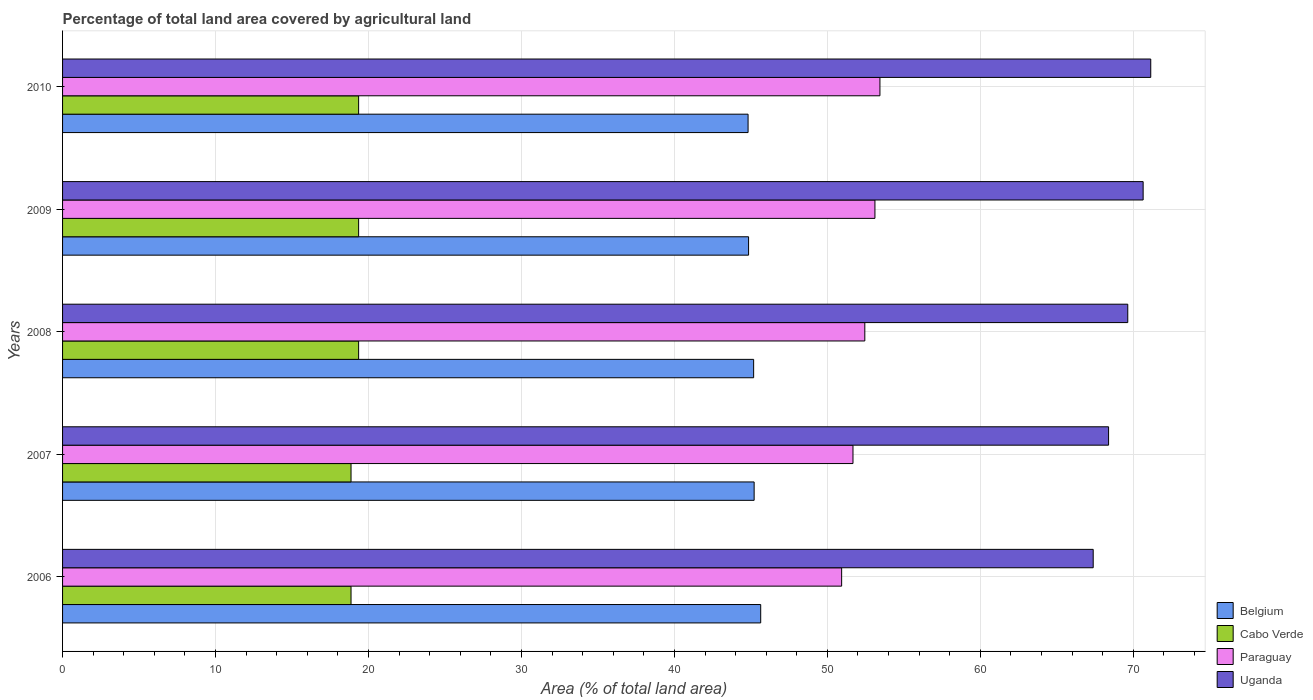How many bars are there on the 4th tick from the top?
Your answer should be compact. 4. What is the label of the 3rd group of bars from the top?
Your answer should be compact. 2008. What is the percentage of agricultural land in Belgium in 2008?
Give a very brief answer. 45.18. Across all years, what is the maximum percentage of agricultural land in Cabo Verde?
Provide a short and direct response. 19.35. Across all years, what is the minimum percentage of agricultural land in Uganda?
Ensure brevity in your answer.  67.38. What is the total percentage of agricultural land in Belgium in the graph?
Make the answer very short. 225.69. What is the difference between the percentage of agricultural land in Cabo Verde in 2007 and that in 2010?
Keep it short and to the point. -0.5. What is the difference between the percentage of agricultural land in Cabo Verde in 2006 and the percentage of agricultural land in Belgium in 2007?
Keep it short and to the point. -26.35. What is the average percentage of agricultural land in Paraguay per year?
Make the answer very short. 52.32. In the year 2007, what is the difference between the percentage of agricultural land in Cabo Verde and percentage of agricultural land in Uganda?
Ensure brevity in your answer.  -49.52. In how many years, is the percentage of agricultural land in Belgium greater than 66 %?
Keep it short and to the point. 0. What is the ratio of the percentage of agricultural land in Paraguay in 2007 to that in 2008?
Your answer should be compact. 0.99. Is the percentage of agricultural land in Cabo Verde in 2008 less than that in 2009?
Your answer should be very brief. No. Is the difference between the percentage of agricultural land in Cabo Verde in 2007 and 2009 greater than the difference between the percentage of agricultural land in Uganda in 2007 and 2009?
Your answer should be very brief. Yes. What is the difference between the highest and the second highest percentage of agricultural land in Uganda?
Your answer should be very brief. 0.5. What is the difference between the highest and the lowest percentage of agricultural land in Belgium?
Offer a very short reply. 0.83. In how many years, is the percentage of agricultural land in Paraguay greater than the average percentage of agricultural land in Paraguay taken over all years?
Give a very brief answer. 3. Is it the case that in every year, the sum of the percentage of agricultural land in Belgium and percentage of agricultural land in Paraguay is greater than the sum of percentage of agricultural land in Uganda and percentage of agricultural land in Cabo Verde?
Your answer should be compact. No. What does the 2nd bar from the top in 2010 represents?
Ensure brevity in your answer.  Paraguay. Is it the case that in every year, the sum of the percentage of agricultural land in Cabo Verde and percentage of agricultural land in Uganda is greater than the percentage of agricultural land in Belgium?
Offer a very short reply. Yes. How many bars are there?
Make the answer very short. 20. What is the difference between two consecutive major ticks on the X-axis?
Your answer should be compact. 10. Does the graph contain any zero values?
Keep it short and to the point. No. Where does the legend appear in the graph?
Make the answer very short. Bottom right. How many legend labels are there?
Offer a very short reply. 4. How are the legend labels stacked?
Offer a very short reply. Vertical. What is the title of the graph?
Your answer should be very brief. Percentage of total land area covered by agricultural land. What is the label or title of the X-axis?
Provide a succinct answer. Area (% of total land area). What is the Area (% of total land area) in Belgium in 2006?
Offer a terse response. 45.64. What is the Area (% of total land area) in Cabo Verde in 2006?
Ensure brevity in your answer.  18.86. What is the Area (% of total land area) in Paraguay in 2006?
Provide a short and direct response. 50.93. What is the Area (% of total land area) of Uganda in 2006?
Ensure brevity in your answer.  67.38. What is the Area (% of total land area) in Belgium in 2007?
Your response must be concise. 45.21. What is the Area (% of total land area) in Cabo Verde in 2007?
Make the answer very short. 18.86. What is the Area (% of total land area) of Paraguay in 2007?
Offer a terse response. 51.67. What is the Area (% of total land area) in Uganda in 2007?
Your answer should be compact. 68.38. What is the Area (% of total land area) in Belgium in 2008?
Give a very brief answer. 45.18. What is the Area (% of total land area) of Cabo Verde in 2008?
Make the answer very short. 19.35. What is the Area (% of total land area) in Paraguay in 2008?
Your answer should be compact. 52.45. What is the Area (% of total land area) of Uganda in 2008?
Give a very brief answer. 69.64. What is the Area (% of total land area) in Belgium in 2009?
Make the answer very short. 44.85. What is the Area (% of total land area) of Cabo Verde in 2009?
Your response must be concise. 19.35. What is the Area (% of total land area) in Paraguay in 2009?
Give a very brief answer. 53.11. What is the Area (% of total land area) in Uganda in 2009?
Ensure brevity in your answer.  70.64. What is the Area (% of total land area) of Belgium in 2010?
Provide a succinct answer. 44.82. What is the Area (% of total land area) in Cabo Verde in 2010?
Provide a succinct answer. 19.35. What is the Area (% of total land area) of Paraguay in 2010?
Your answer should be compact. 53.44. What is the Area (% of total land area) in Uganda in 2010?
Offer a very short reply. 71.14. Across all years, what is the maximum Area (% of total land area) of Belgium?
Your answer should be compact. 45.64. Across all years, what is the maximum Area (% of total land area) in Cabo Verde?
Your response must be concise. 19.35. Across all years, what is the maximum Area (% of total land area) in Paraguay?
Provide a short and direct response. 53.44. Across all years, what is the maximum Area (% of total land area) of Uganda?
Your answer should be very brief. 71.14. Across all years, what is the minimum Area (% of total land area) in Belgium?
Offer a very short reply. 44.82. Across all years, what is the minimum Area (% of total land area) in Cabo Verde?
Offer a very short reply. 18.86. Across all years, what is the minimum Area (% of total land area) in Paraguay?
Offer a terse response. 50.93. Across all years, what is the minimum Area (% of total land area) in Uganda?
Make the answer very short. 67.38. What is the total Area (% of total land area) in Belgium in the graph?
Offer a terse response. 225.69. What is the total Area (% of total land area) of Cabo Verde in the graph?
Provide a short and direct response. 95.78. What is the total Area (% of total land area) of Paraguay in the graph?
Your answer should be very brief. 261.6. What is the total Area (% of total land area) of Uganda in the graph?
Your response must be concise. 347.18. What is the difference between the Area (% of total land area) of Belgium in 2006 and that in 2007?
Give a very brief answer. 0.43. What is the difference between the Area (% of total land area) of Paraguay in 2006 and that in 2007?
Your response must be concise. -0.74. What is the difference between the Area (% of total land area) in Uganda in 2006 and that in 2007?
Keep it short and to the point. -1. What is the difference between the Area (% of total land area) in Belgium in 2006 and that in 2008?
Your answer should be very brief. 0.46. What is the difference between the Area (% of total land area) in Cabo Verde in 2006 and that in 2008?
Offer a terse response. -0.5. What is the difference between the Area (% of total land area) of Paraguay in 2006 and that in 2008?
Provide a short and direct response. -1.52. What is the difference between the Area (% of total land area) in Uganda in 2006 and that in 2008?
Offer a terse response. -2.26. What is the difference between the Area (% of total land area) in Belgium in 2006 and that in 2009?
Ensure brevity in your answer.  0.79. What is the difference between the Area (% of total land area) of Cabo Verde in 2006 and that in 2009?
Offer a terse response. -0.5. What is the difference between the Area (% of total land area) of Paraguay in 2006 and that in 2009?
Provide a short and direct response. -2.18. What is the difference between the Area (% of total land area) in Uganda in 2006 and that in 2009?
Give a very brief answer. -3.26. What is the difference between the Area (% of total land area) of Belgium in 2006 and that in 2010?
Offer a very short reply. 0.83. What is the difference between the Area (% of total land area) in Cabo Verde in 2006 and that in 2010?
Offer a very short reply. -0.5. What is the difference between the Area (% of total land area) of Paraguay in 2006 and that in 2010?
Your answer should be very brief. -2.5. What is the difference between the Area (% of total land area) in Uganda in 2006 and that in 2010?
Your answer should be very brief. -3.76. What is the difference between the Area (% of total land area) in Belgium in 2007 and that in 2008?
Provide a succinct answer. 0.03. What is the difference between the Area (% of total land area) in Cabo Verde in 2007 and that in 2008?
Ensure brevity in your answer.  -0.5. What is the difference between the Area (% of total land area) in Paraguay in 2007 and that in 2008?
Make the answer very short. -0.77. What is the difference between the Area (% of total land area) in Uganda in 2007 and that in 2008?
Ensure brevity in your answer.  -1.25. What is the difference between the Area (% of total land area) of Belgium in 2007 and that in 2009?
Provide a short and direct response. 0.36. What is the difference between the Area (% of total land area) in Cabo Verde in 2007 and that in 2009?
Offer a terse response. -0.5. What is the difference between the Area (% of total land area) of Paraguay in 2007 and that in 2009?
Your answer should be very brief. -1.43. What is the difference between the Area (% of total land area) in Uganda in 2007 and that in 2009?
Provide a succinct answer. -2.26. What is the difference between the Area (% of total land area) in Belgium in 2007 and that in 2010?
Provide a short and direct response. 0.4. What is the difference between the Area (% of total land area) of Cabo Verde in 2007 and that in 2010?
Offer a terse response. -0.5. What is the difference between the Area (% of total land area) of Paraguay in 2007 and that in 2010?
Give a very brief answer. -1.76. What is the difference between the Area (% of total land area) in Uganda in 2007 and that in 2010?
Keep it short and to the point. -2.76. What is the difference between the Area (% of total land area) in Belgium in 2008 and that in 2009?
Your answer should be very brief. 0.33. What is the difference between the Area (% of total land area) of Cabo Verde in 2008 and that in 2009?
Provide a short and direct response. 0. What is the difference between the Area (% of total land area) of Paraguay in 2008 and that in 2009?
Make the answer very short. -0.66. What is the difference between the Area (% of total land area) in Uganda in 2008 and that in 2009?
Provide a short and direct response. -1. What is the difference between the Area (% of total land area) in Belgium in 2008 and that in 2010?
Your answer should be compact. 0.36. What is the difference between the Area (% of total land area) in Paraguay in 2008 and that in 2010?
Offer a very short reply. -0.99. What is the difference between the Area (% of total land area) in Uganda in 2008 and that in 2010?
Provide a short and direct response. -1.5. What is the difference between the Area (% of total land area) in Belgium in 2009 and that in 2010?
Provide a short and direct response. 0.03. What is the difference between the Area (% of total land area) in Cabo Verde in 2009 and that in 2010?
Provide a succinct answer. 0. What is the difference between the Area (% of total land area) in Paraguay in 2009 and that in 2010?
Offer a terse response. -0.33. What is the difference between the Area (% of total land area) in Uganda in 2009 and that in 2010?
Keep it short and to the point. -0.5. What is the difference between the Area (% of total land area) in Belgium in 2006 and the Area (% of total land area) in Cabo Verde in 2007?
Provide a succinct answer. 26.78. What is the difference between the Area (% of total land area) of Belgium in 2006 and the Area (% of total land area) of Paraguay in 2007?
Your response must be concise. -6.03. What is the difference between the Area (% of total land area) in Belgium in 2006 and the Area (% of total land area) in Uganda in 2007?
Provide a succinct answer. -22.74. What is the difference between the Area (% of total land area) in Cabo Verde in 2006 and the Area (% of total land area) in Paraguay in 2007?
Ensure brevity in your answer.  -32.82. What is the difference between the Area (% of total land area) of Cabo Verde in 2006 and the Area (% of total land area) of Uganda in 2007?
Your answer should be very brief. -49.52. What is the difference between the Area (% of total land area) of Paraguay in 2006 and the Area (% of total land area) of Uganda in 2007?
Offer a very short reply. -17.45. What is the difference between the Area (% of total land area) in Belgium in 2006 and the Area (% of total land area) in Cabo Verde in 2008?
Offer a very short reply. 26.29. What is the difference between the Area (% of total land area) of Belgium in 2006 and the Area (% of total land area) of Paraguay in 2008?
Offer a very short reply. -6.81. What is the difference between the Area (% of total land area) in Belgium in 2006 and the Area (% of total land area) in Uganda in 2008?
Give a very brief answer. -24. What is the difference between the Area (% of total land area) of Cabo Verde in 2006 and the Area (% of total land area) of Paraguay in 2008?
Provide a succinct answer. -33.59. What is the difference between the Area (% of total land area) of Cabo Verde in 2006 and the Area (% of total land area) of Uganda in 2008?
Make the answer very short. -50.78. What is the difference between the Area (% of total land area) of Paraguay in 2006 and the Area (% of total land area) of Uganda in 2008?
Offer a terse response. -18.71. What is the difference between the Area (% of total land area) of Belgium in 2006 and the Area (% of total land area) of Cabo Verde in 2009?
Your response must be concise. 26.29. What is the difference between the Area (% of total land area) of Belgium in 2006 and the Area (% of total land area) of Paraguay in 2009?
Keep it short and to the point. -7.47. What is the difference between the Area (% of total land area) in Belgium in 2006 and the Area (% of total land area) in Uganda in 2009?
Give a very brief answer. -25. What is the difference between the Area (% of total land area) of Cabo Verde in 2006 and the Area (% of total land area) of Paraguay in 2009?
Provide a succinct answer. -34.25. What is the difference between the Area (% of total land area) in Cabo Verde in 2006 and the Area (% of total land area) in Uganda in 2009?
Provide a succinct answer. -51.78. What is the difference between the Area (% of total land area) of Paraguay in 2006 and the Area (% of total land area) of Uganda in 2009?
Make the answer very short. -19.71. What is the difference between the Area (% of total land area) in Belgium in 2006 and the Area (% of total land area) in Cabo Verde in 2010?
Provide a short and direct response. 26.29. What is the difference between the Area (% of total land area) in Belgium in 2006 and the Area (% of total land area) in Paraguay in 2010?
Offer a very short reply. -7.79. What is the difference between the Area (% of total land area) in Belgium in 2006 and the Area (% of total land area) in Uganda in 2010?
Your answer should be compact. -25.5. What is the difference between the Area (% of total land area) in Cabo Verde in 2006 and the Area (% of total land area) in Paraguay in 2010?
Offer a terse response. -34.58. What is the difference between the Area (% of total land area) in Cabo Verde in 2006 and the Area (% of total land area) in Uganda in 2010?
Make the answer very short. -52.28. What is the difference between the Area (% of total land area) of Paraguay in 2006 and the Area (% of total land area) of Uganda in 2010?
Your answer should be very brief. -20.21. What is the difference between the Area (% of total land area) of Belgium in 2007 and the Area (% of total land area) of Cabo Verde in 2008?
Provide a succinct answer. 25.86. What is the difference between the Area (% of total land area) of Belgium in 2007 and the Area (% of total land area) of Paraguay in 2008?
Offer a very short reply. -7.24. What is the difference between the Area (% of total land area) of Belgium in 2007 and the Area (% of total land area) of Uganda in 2008?
Ensure brevity in your answer.  -24.43. What is the difference between the Area (% of total land area) in Cabo Verde in 2007 and the Area (% of total land area) in Paraguay in 2008?
Provide a succinct answer. -33.59. What is the difference between the Area (% of total land area) of Cabo Verde in 2007 and the Area (% of total land area) of Uganda in 2008?
Ensure brevity in your answer.  -50.78. What is the difference between the Area (% of total land area) in Paraguay in 2007 and the Area (% of total land area) in Uganda in 2008?
Your answer should be very brief. -17.96. What is the difference between the Area (% of total land area) in Belgium in 2007 and the Area (% of total land area) in Cabo Verde in 2009?
Provide a short and direct response. 25.86. What is the difference between the Area (% of total land area) of Belgium in 2007 and the Area (% of total land area) of Paraguay in 2009?
Offer a very short reply. -7.9. What is the difference between the Area (% of total land area) of Belgium in 2007 and the Area (% of total land area) of Uganda in 2009?
Provide a succinct answer. -25.43. What is the difference between the Area (% of total land area) in Cabo Verde in 2007 and the Area (% of total land area) in Paraguay in 2009?
Your answer should be very brief. -34.25. What is the difference between the Area (% of total land area) in Cabo Verde in 2007 and the Area (% of total land area) in Uganda in 2009?
Ensure brevity in your answer.  -51.78. What is the difference between the Area (% of total land area) in Paraguay in 2007 and the Area (% of total land area) in Uganda in 2009?
Provide a short and direct response. -18.97. What is the difference between the Area (% of total land area) of Belgium in 2007 and the Area (% of total land area) of Cabo Verde in 2010?
Keep it short and to the point. 25.86. What is the difference between the Area (% of total land area) of Belgium in 2007 and the Area (% of total land area) of Paraguay in 2010?
Offer a very short reply. -8.22. What is the difference between the Area (% of total land area) in Belgium in 2007 and the Area (% of total land area) in Uganda in 2010?
Your response must be concise. -25.93. What is the difference between the Area (% of total land area) of Cabo Verde in 2007 and the Area (% of total land area) of Paraguay in 2010?
Ensure brevity in your answer.  -34.58. What is the difference between the Area (% of total land area) in Cabo Verde in 2007 and the Area (% of total land area) in Uganda in 2010?
Provide a short and direct response. -52.28. What is the difference between the Area (% of total land area) of Paraguay in 2007 and the Area (% of total land area) of Uganda in 2010?
Give a very brief answer. -19.47. What is the difference between the Area (% of total land area) of Belgium in 2008 and the Area (% of total land area) of Cabo Verde in 2009?
Ensure brevity in your answer.  25.82. What is the difference between the Area (% of total land area) of Belgium in 2008 and the Area (% of total land area) of Paraguay in 2009?
Give a very brief answer. -7.93. What is the difference between the Area (% of total land area) in Belgium in 2008 and the Area (% of total land area) in Uganda in 2009?
Offer a very short reply. -25.46. What is the difference between the Area (% of total land area) in Cabo Verde in 2008 and the Area (% of total land area) in Paraguay in 2009?
Your answer should be compact. -33.75. What is the difference between the Area (% of total land area) of Cabo Verde in 2008 and the Area (% of total land area) of Uganda in 2009?
Your answer should be compact. -51.29. What is the difference between the Area (% of total land area) in Paraguay in 2008 and the Area (% of total land area) in Uganda in 2009?
Your response must be concise. -18.2. What is the difference between the Area (% of total land area) in Belgium in 2008 and the Area (% of total land area) in Cabo Verde in 2010?
Offer a terse response. 25.82. What is the difference between the Area (% of total land area) in Belgium in 2008 and the Area (% of total land area) in Paraguay in 2010?
Your answer should be compact. -8.26. What is the difference between the Area (% of total land area) of Belgium in 2008 and the Area (% of total land area) of Uganda in 2010?
Your answer should be compact. -25.96. What is the difference between the Area (% of total land area) in Cabo Verde in 2008 and the Area (% of total land area) in Paraguay in 2010?
Offer a terse response. -34.08. What is the difference between the Area (% of total land area) in Cabo Verde in 2008 and the Area (% of total land area) in Uganda in 2010?
Offer a very short reply. -51.79. What is the difference between the Area (% of total land area) of Paraguay in 2008 and the Area (% of total land area) of Uganda in 2010?
Offer a very short reply. -18.69. What is the difference between the Area (% of total land area) of Belgium in 2009 and the Area (% of total land area) of Cabo Verde in 2010?
Your response must be concise. 25.49. What is the difference between the Area (% of total land area) of Belgium in 2009 and the Area (% of total land area) of Paraguay in 2010?
Offer a very short reply. -8.59. What is the difference between the Area (% of total land area) in Belgium in 2009 and the Area (% of total land area) in Uganda in 2010?
Your response must be concise. -26.29. What is the difference between the Area (% of total land area) of Cabo Verde in 2009 and the Area (% of total land area) of Paraguay in 2010?
Offer a terse response. -34.08. What is the difference between the Area (% of total land area) in Cabo Verde in 2009 and the Area (% of total land area) in Uganda in 2010?
Provide a short and direct response. -51.79. What is the difference between the Area (% of total land area) in Paraguay in 2009 and the Area (% of total land area) in Uganda in 2010?
Offer a terse response. -18.03. What is the average Area (% of total land area) in Belgium per year?
Make the answer very short. 45.14. What is the average Area (% of total land area) in Cabo Verde per year?
Provide a succinct answer. 19.16. What is the average Area (% of total land area) in Paraguay per year?
Offer a terse response. 52.32. What is the average Area (% of total land area) of Uganda per year?
Provide a short and direct response. 69.44. In the year 2006, what is the difference between the Area (% of total land area) of Belgium and Area (% of total land area) of Cabo Verde?
Provide a short and direct response. 26.78. In the year 2006, what is the difference between the Area (% of total land area) of Belgium and Area (% of total land area) of Paraguay?
Give a very brief answer. -5.29. In the year 2006, what is the difference between the Area (% of total land area) of Belgium and Area (% of total land area) of Uganda?
Keep it short and to the point. -21.74. In the year 2006, what is the difference between the Area (% of total land area) in Cabo Verde and Area (% of total land area) in Paraguay?
Provide a short and direct response. -32.07. In the year 2006, what is the difference between the Area (% of total land area) in Cabo Verde and Area (% of total land area) in Uganda?
Your response must be concise. -48.52. In the year 2006, what is the difference between the Area (% of total land area) of Paraguay and Area (% of total land area) of Uganda?
Provide a succinct answer. -16.45. In the year 2007, what is the difference between the Area (% of total land area) in Belgium and Area (% of total land area) in Cabo Verde?
Provide a succinct answer. 26.35. In the year 2007, what is the difference between the Area (% of total land area) in Belgium and Area (% of total land area) in Paraguay?
Your response must be concise. -6.46. In the year 2007, what is the difference between the Area (% of total land area) in Belgium and Area (% of total land area) in Uganda?
Your response must be concise. -23.17. In the year 2007, what is the difference between the Area (% of total land area) of Cabo Verde and Area (% of total land area) of Paraguay?
Provide a succinct answer. -32.82. In the year 2007, what is the difference between the Area (% of total land area) in Cabo Verde and Area (% of total land area) in Uganda?
Make the answer very short. -49.52. In the year 2007, what is the difference between the Area (% of total land area) of Paraguay and Area (% of total land area) of Uganda?
Provide a succinct answer. -16.71. In the year 2008, what is the difference between the Area (% of total land area) of Belgium and Area (% of total land area) of Cabo Verde?
Your response must be concise. 25.82. In the year 2008, what is the difference between the Area (% of total land area) in Belgium and Area (% of total land area) in Paraguay?
Your answer should be very brief. -7.27. In the year 2008, what is the difference between the Area (% of total land area) in Belgium and Area (% of total land area) in Uganda?
Your response must be concise. -24.46. In the year 2008, what is the difference between the Area (% of total land area) of Cabo Verde and Area (% of total land area) of Paraguay?
Give a very brief answer. -33.09. In the year 2008, what is the difference between the Area (% of total land area) in Cabo Verde and Area (% of total land area) in Uganda?
Your answer should be compact. -50.28. In the year 2008, what is the difference between the Area (% of total land area) in Paraguay and Area (% of total land area) in Uganda?
Offer a terse response. -17.19. In the year 2009, what is the difference between the Area (% of total land area) in Belgium and Area (% of total land area) in Cabo Verde?
Provide a succinct answer. 25.49. In the year 2009, what is the difference between the Area (% of total land area) of Belgium and Area (% of total land area) of Paraguay?
Make the answer very short. -8.26. In the year 2009, what is the difference between the Area (% of total land area) in Belgium and Area (% of total land area) in Uganda?
Offer a terse response. -25.79. In the year 2009, what is the difference between the Area (% of total land area) of Cabo Verde and Area (% of total land area) of Paraguay?
Your response must be concise. -33.75. In the year 2009, what is the difference between the Area (% of total land area) of Cabo Verde and Area (% of total land area) of Uganda?
Ensure brevity in your answer.  -51.29. In the year 2009, what is the difference between the Area (% of total land area) in Paraguay and Area (% of total land area) in Uganda?
Keep it short and to the point. -17.53. In the year 2010, what is the difference between the Area (% of total land area) of Belgium and Area (% of total land area) of Cabo Verde?
Your answer should be compact. 25.46. In the year 2010, what is the difference between the Area (% of total land area) of Belgium and Area (% of total land area) of Paraguay?
Your response must be concise. -8.62. In the year 2010, what is the difference between the Area (% of total land area) of Belgium and Area (% of total land area) of Uganda?
Offer a very short reply. -26.32. In the year 2010, what is the difference between the Area (% of total land area) of Cabo Verde and Area (% of total land area) of Paraguay?
Make the answer very short. -34.08. In the year 2010, what is the difference between the Area (% of total land area) of Cabo Verde and Area (% of total land area) of Uganda?
Ensure brevity in your answer.  -51.79. In the year 2010, what is the difference between the Area (% of total land area) in Paraguay and Area (% of total land area) in Uganda?
Your answer should be very brief. -17.7. What is the ratio of the Area (% of total land area) of Belgium in 2006 to that in 2007?
Provide a short and direct response. 1.01. What is the ratio of the Area (% of total land area) of Paraguay in 2006 to that in 2007?
Ensure brevity in your answer.  0.99. What is the ratio of the Area (% of total land area) of Belgium in 2006 to that in 2008?
Provide a succinct answer. 1.01. What is the ratio of the Area (% of total land area) in Cabo Verde in 2006 to that in 2008?
Provide a short and direct response. 0.97. What is the ratio of the Area (% of total land area) of Paraguay in 2006 to that in 2008?
Your answer should be compact. 0.97. What is the ratio of the Area (% of total land area) in Uganda in 2006 to that in 2008?
Your response must be concise. 0.97. What is the ratio of the Area (% of total land area) in Belgium in 2006 to that in 2009?
Keep it short and to the point. 1.02. What is the ratio of the Area (% of total land area) of Cabo Verde in 2006 to that in 2009?
Keep it short and to the point. 0.97. What is the ratio of the Area (% of total land area) of Uganda in 2006 to that in 2009?
Keep it short and to the point. 0.95. What is the ratio of the Area (% of total land area) in Belgium in 2006 to that in 2010?
Ensure brevity in your answer.  1.02. What is the ratio of the Area (% of total land area) of Cabo Verde in 2006 to that in 2010?
Ensure brevity in your answer.  0.97. What is the ratio of the Area (% of total land area) in Paraguay in 2006 to that in 2010?
Your answer should be very brief. 0.95. What is the ratio of the Area (% of total land area) of Uganda in 2006 to that in 2010?
Give a very brief answer. 0.95. What is the ratio of the Area (% of total land area) of Cabo Verde in 2007 to that in 2008?
Ensure brevity in your answer.  0.97. What is the ratio of the Area (% of total land area) of Uganda in 2007 to that in 2008?
Offer a very short reply. 0.98. What is the ratio of the Area (% of total land area) in Belgium in 2007 to that in 2009?
Your answer should be very brief. 1.01. What is the ratio of the Area (% of total land area) of Cabo Verde in 2007 to that in 2009?
Keep it short and to the point. 0.97. What is the ratio of the Area (% of total land area) of Paraguay in 2007 to that in 2009?
Provide a succinct answer. 0.97. What is the ratio of the Area (% of total land area) of Uganda in 2007 to that in 2009?
Your response must be concise. 0.97. What is the ratio of the Area (% of total land area) of Belgium in 2007 to that in 2010?
Your answer should be compact. 1.01. What is the ratio of the Area (% of total land area) of Cabo Verde in 2007 to that in 2010?
Your answer should be compact. 0.97. What is the ratio of the Area (% of total land area) of Paraguay in 2007 to that in 2010?
Offer a very short reply. 0.97. What is the ratio of the Area (% of total land area) in Uganda in 2007 to that in 2010?
Keep it short and to the point. 0.96. What is the ratio of the Area (% of total land area) of Belgium in 2008 to that in 2009?
Provide a short and direct response. 1.01. What is the ratio of the Area (% of total land area) of Cabo Verde in 2008 to that in 2009?
Offer a very short reply. 1. What is the ratio of the Area (% of total land area) in Paraguay in 2008 to that in 2009?
Your answer should be very brief. 0.99. What is the ratio of the Area (% of total land area) of Uganda in 2008 to that in 2009?
Keep it short and to the point. 0.99. What is the ratio of the Area (% of total land area) in Paraguay in 2008 to that in 2010?
Provide a succinct answer. 0.98. What is the ratio of the Area (% of total land area) in Uganda in 2008 to that in 2010?
Your answer should be compact. 0.98. What is the ratio of the Area (% of total land area) in Uganda in 2009 to that in 2010?
Provide a short and direct response. 0.99. What is the difference between the highest and the second highest Area (% of total land area) in Belgium?
Ensure brevity in your answer.  0.43. What is the difference between the highest and the second highest Area (% of total land area) of Cabo Verde?
Make the answer very short. 0. What is the difference between the highest and the second highest Area (% of total land area) of Paraguay?
Offer a terse response. 0.33. What is the difference between the highest and the second highest Area (% of total land area) of Uganda?
Offer a very short reply. 0.5. What is the difference between the highest and the lowest Area (% of total land area) in Belgium?
Provide a succinct answer. 0.83. What is the difference between the highest and the lowest Area (% of total land area) in Cabo Verde?
Provide a succinct answer. 0.5. What is the difference between the highest and the lowest Area (% of total land area) in Paraguay?
Your response must be concise. 2.5. What is the difference between the highest and the lowest Area (% of total land area) in Uganda?
Ensure brevity in your answer.  3.76. 